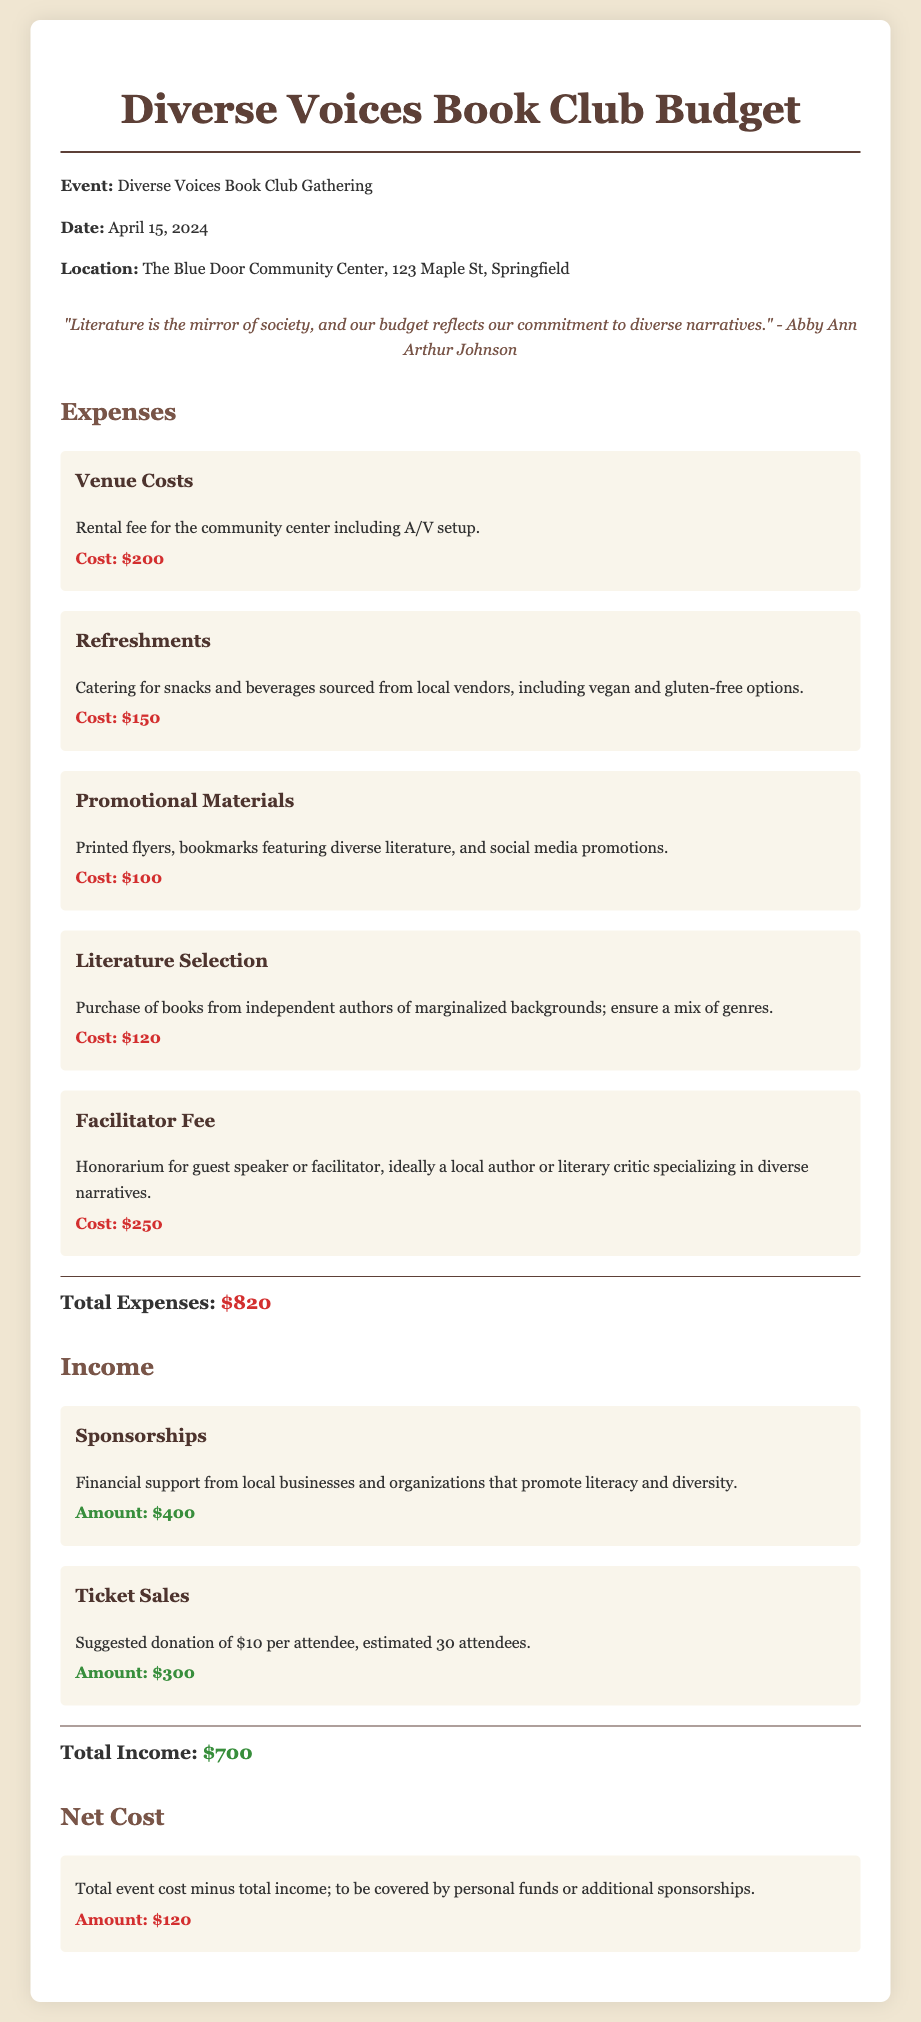What is the event date? The event date is specifically mentioned in the document as April 15, 2024.
Answer: April 15, 2024 What is the total cost of venue rental? Venue costs are detailed in the budget, with the rental fee specified as $200.
Answer: $200 How much is allocated for refreshments? Refreshments have a cost assigned in the document, which is stated as $150.
Answer: $150 What is the total of income from sponsorships? The income from sponsorships is clearly stated as $400.
Answer: $400 What is the total cost of purchasing literature? The budget specifies the literature selection cost as $120.
Answer: $120 What is the estimated number of attendees? The document estimates the number of attendees to be 30.
Answer: 30 What is the total for promotional materials? According to the budget, the cost for promotional materials is outlined as $100.
Answer: $100 What is the net cost for the event? The net cost is calculated by subtracting total income from total expenses, resulting in $120.
Answer: $120 What is the fee for the facilitator? The document lists the facilitator fee as $250.
Answer: $250 